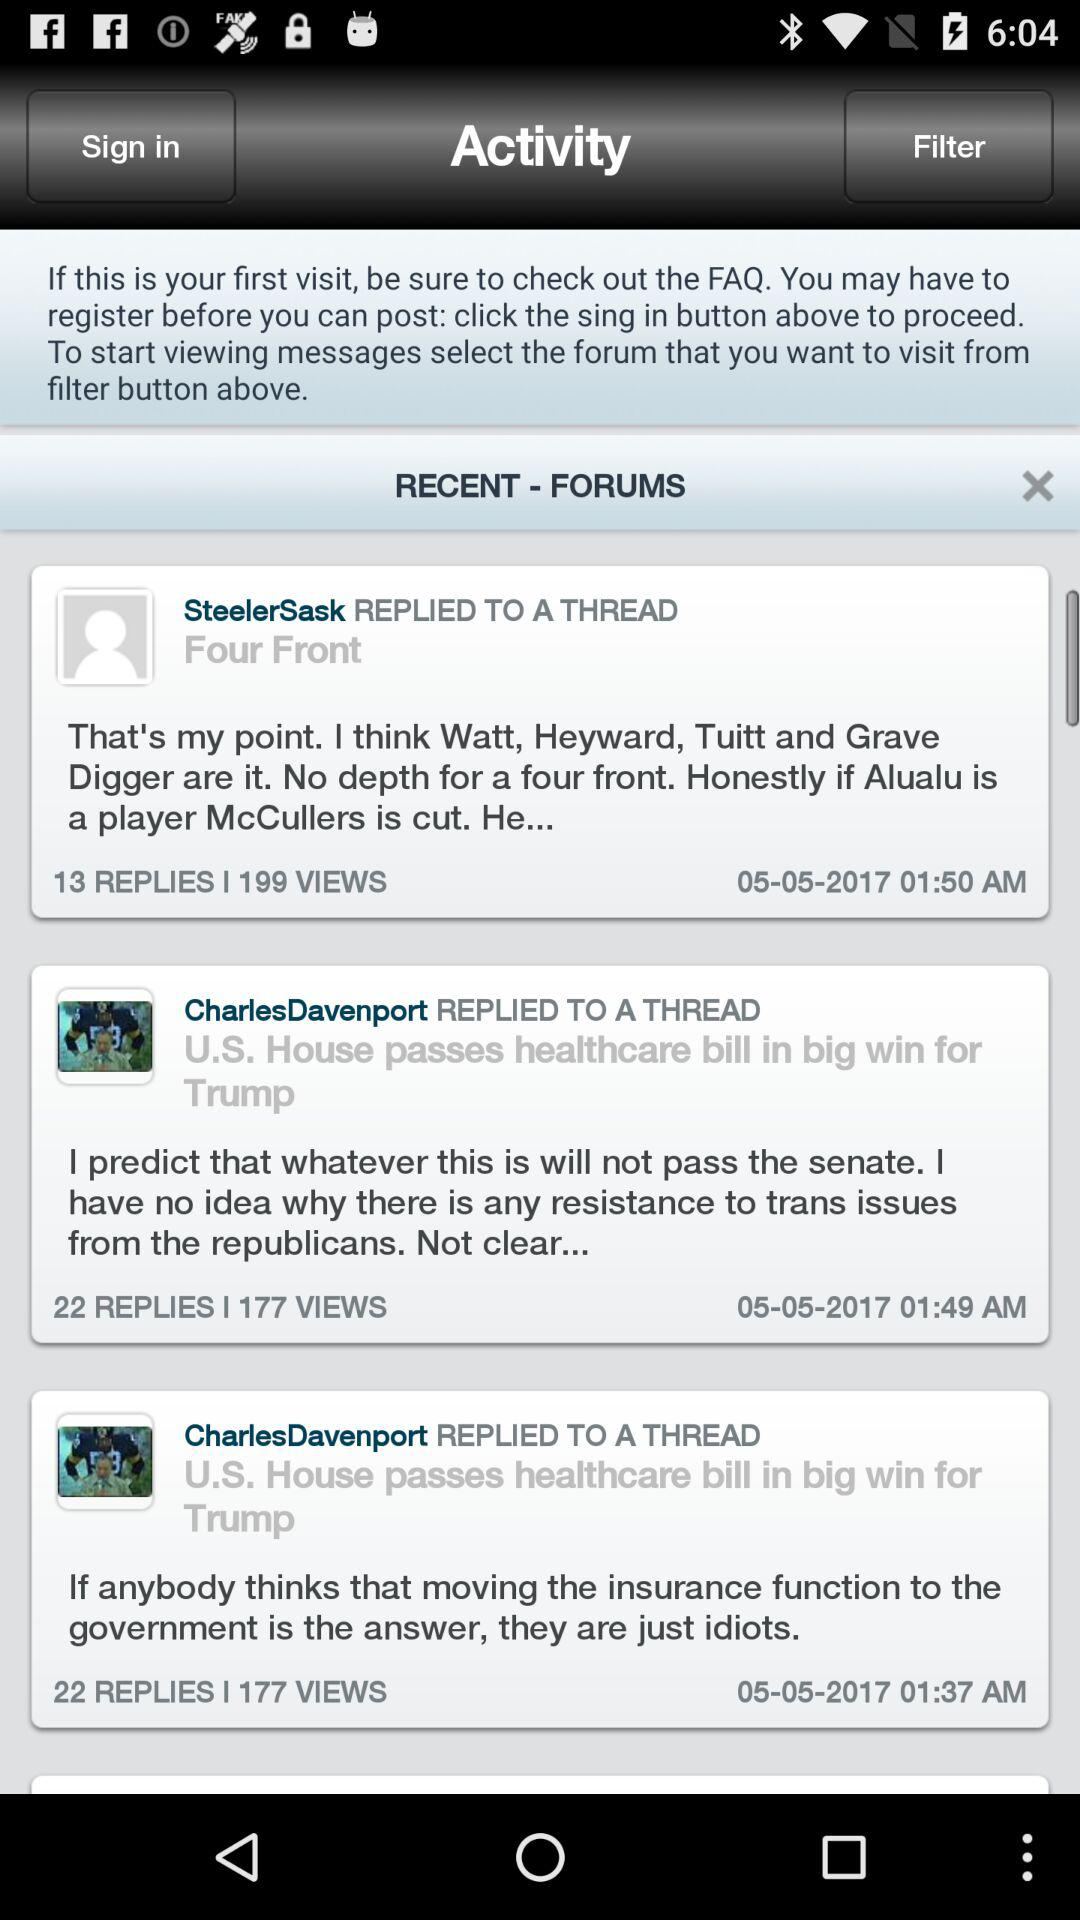On what date did Charles Davenport reply to a thread? Charles Davenport replied to a thread on May 5, 2017. 